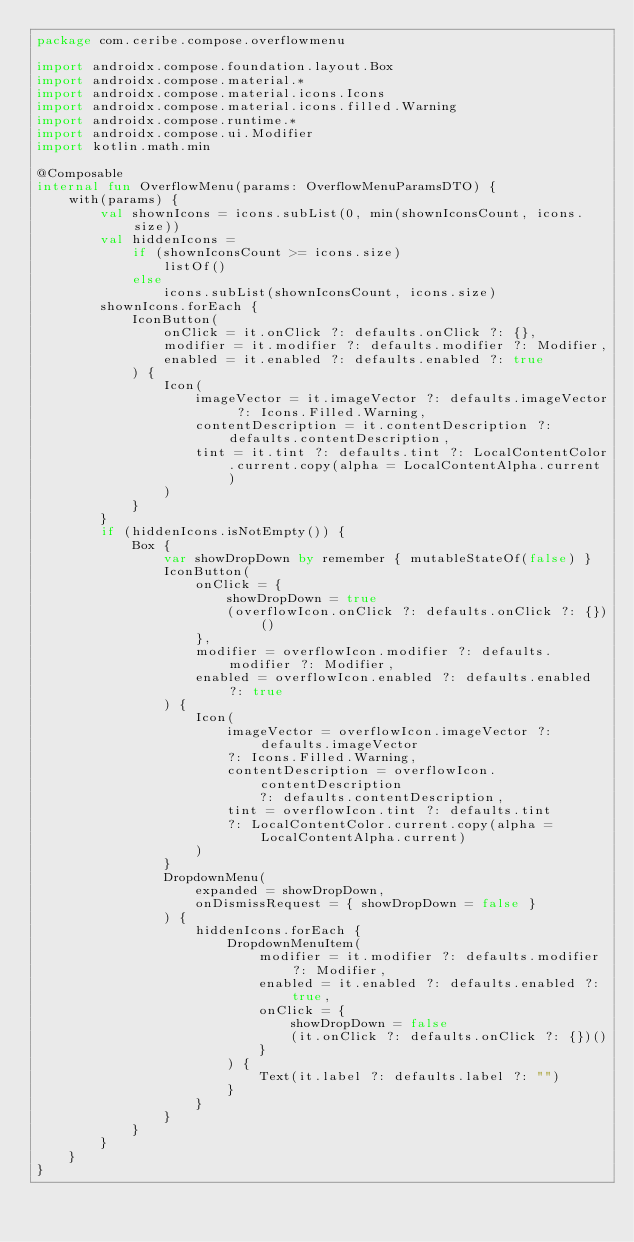Convert code to text. <code><loc_0><loc_0><loc_500><loc_500><_Kotlin_>package com.ceribe.compose.overflowmenu

import androidx.compose.foundation.layout.Box
import androidx.compose.material.*
import androidx.compose.material.icons.Icons
import androidx.compose.material.icons.filled.Warning
import androidx.compose.runtime.*
import androidx.compose.ui.Modifier
import kotlin.math.min

@Composable
internal fun OverflowMenu(params: OverflowMenuParamsDTO) {
    with(params) {
        val shownIcons = icons.subList(0, min(shownIconsCount, icons.size))
        val hiddenIcons =
            if (shownIconsCount >= icons.size)
                listOf()
            else
                icons.subList(shownIconsCount, icons.size)
        shownIcons.forEach {
            IconButton(
                onClick = it.onClick ?: defaults.onClick ?: {},
                modifier = it.modifier ?: defaults.modifier ?: Modifier,
                enabled = it.enabled ?: defaults.enabled ?: true
            ) {
                Icon(
                    imageVector = it.imageVector ?: defaults.imageVector ?: Icons.Filled.Warning,
                    contentDescription = it.contentDescription ?: defaults.contentDescription,
                    tint = it.tint ?: defaults.tint ?: LocalContentColor.current.copy(alpha = LocalContentAlpha.current)
                )
            }
        }
        if (hiddenIcons.isNotEmpty()) {
            Box {
                var showDropDown by remember { mutableStateOf(false) }
                IconButton(
                    onClick = {
                        showDropDown = true
                        (overflowIcon.onClick ?: defaults.onClick ?: {})()
                    },
                    modifier = overflowIcon.modifier ?: defaults.modifier ?: Modifier,
                    enabled = overflowIcon.enabled ?: defaults.enabled ?: true
                ) {
                    Icon(
                        imageVector = overflowIcon.imageVector ?: defaults.imageVector
                        ?: Icons.Filled.Warning,
                        contentDescription = overflowIcon.contentDescription
                            ?: defaults.contentDescription,
                        tint = overflowIcon.tint ?: defaults.tint
                        ?: LocalContentColor.current.copy(alpha = LocalContentAlpha.current)
                    )
                }
                DropdownMenu(
                    expanded = showDropDown,
                    onDismissRequest = { showDropDown = false }
                ) {
                    hiddenIcons.forEach {
                        DropdownMenuItem(
                            modifier = it.modifier ?: defaults.modifier ?: Modifier,
                            enabled = it.enabled ?: defaults.enabled ?: true,
                            onClick = {
                                showDropDown = false
                                (it.onClick ?: defaults.onClick ?: {})()
                            }
                        ) {
                            Text(it.label ?: defaults.label ?: "")
                        }
                    }
                }
            }
        }
    }
}
</code> 